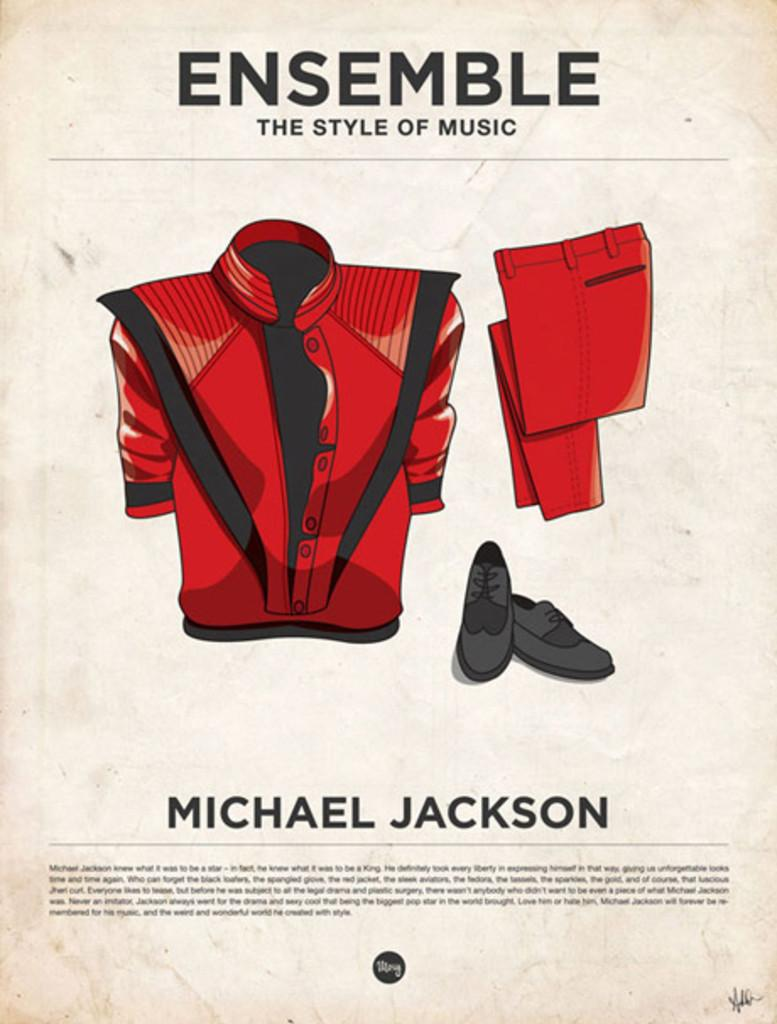<image>
Render a clear and concise summary of the photo. A poster shows the red outfit made famous by Michael Jackson. 